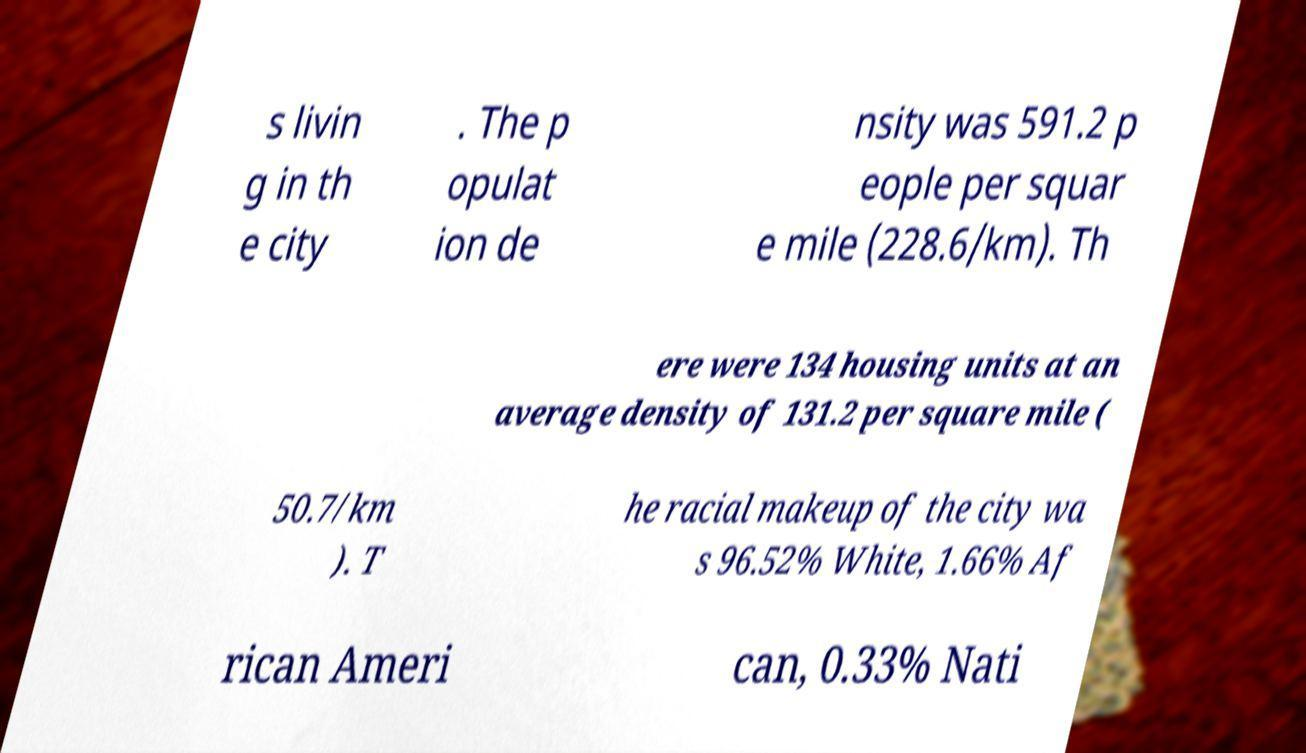There's text embedded in this image that I need extracted. Can you transcribe it verbatim? s livin g in th e city . The p opulat ion de nsity was 591.2 p eople per squar e mile (228.6/km). Th ere were 134 housing units at an average density of 131.2 per square mile ( 50.7/km ). T he racial makeup of the city wa s 96.52% White, 1.66% Af rican Ameri can, 0.33% Nati 